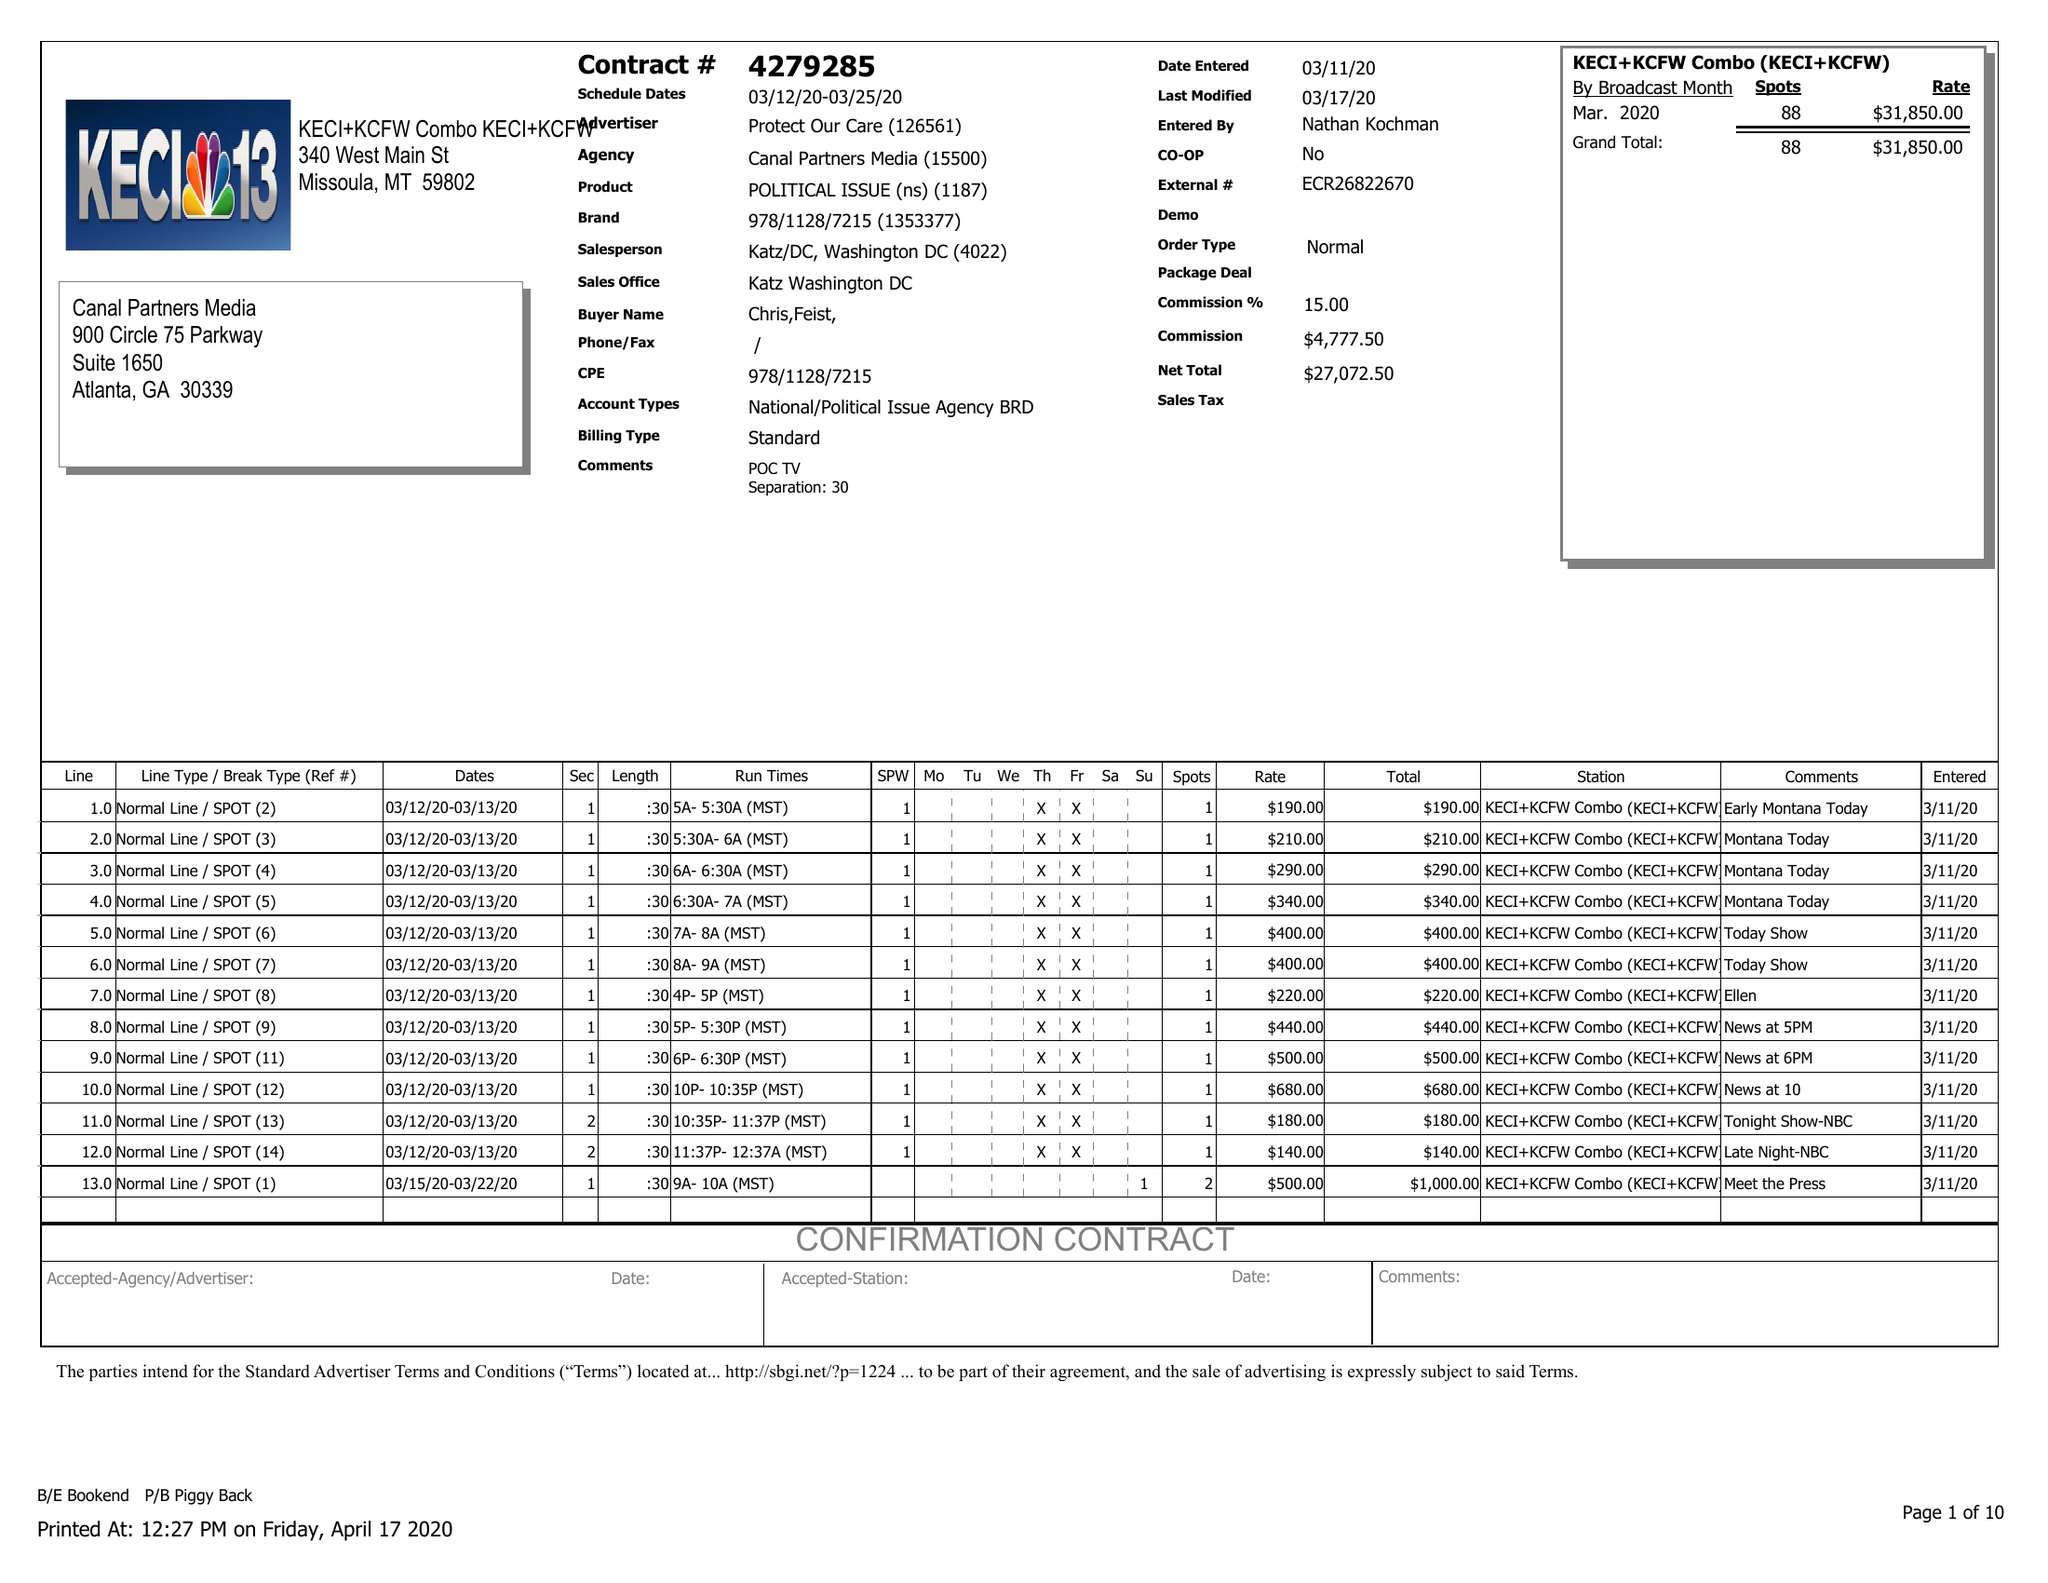What is the value for the flight_from?
Answer the question using a single word or phrase. 03/12/20 